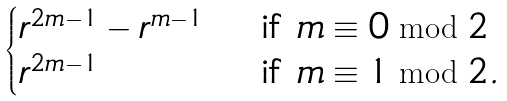Convert formula to latex. <formula><loc_0><loc_0><loc_500><loc_500>\begin{cases} r ^ { 2 m - 1 } - r ^ { m - 1 } & \text {\ if\ } m \equiv 0 \bmod 2 \\ r ^ { 2 m - 1 } & \text {\ if\ } m \equiv 1 \bmod 2 . \end{cases}</formula> 